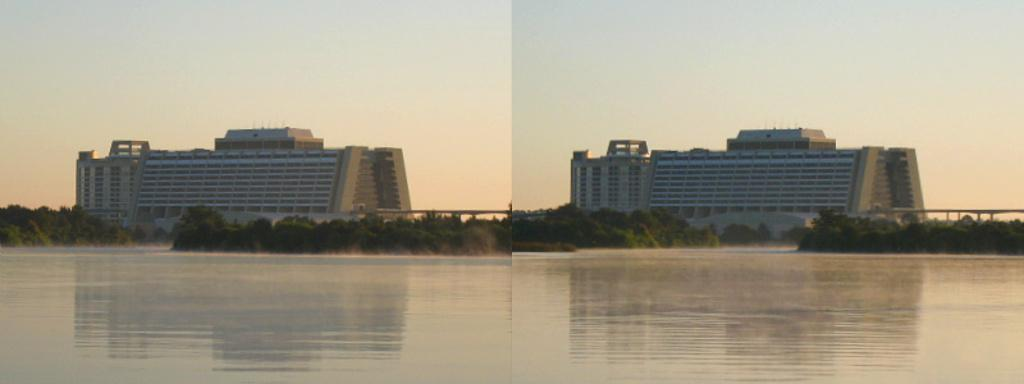What type of artwork is the image? The image is a collage. What structures can be seen in the collage? There are buildings in the image. What type of natural elements are present in the collage? There are trees in the image. What part of the sky is visible in the collage? The sky is visible in the image. What is at the bottom of the collage? There is water at the bottom of the image. What type of stove can be seen in the image? There is no stove present in the image. Who is the writer in the image? There is no writer depicted in the image. 